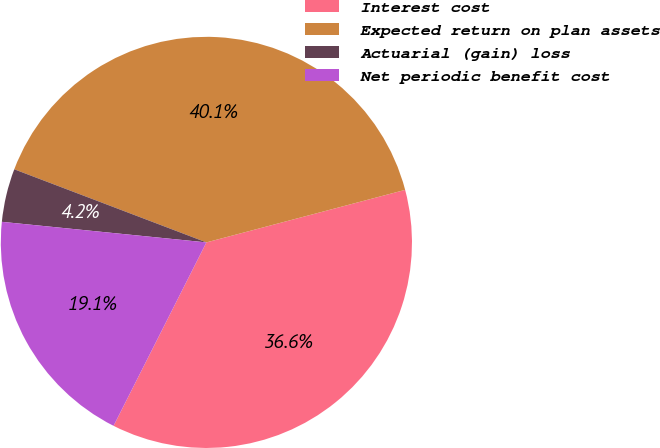Convert chart. <chart><loc_0><loc_0><loc_500><loc_500><pie_chart><fcel>Interest cost<fcel>Expected return on plan assets<fcel>Actuarial (gain) loss<fcel>Net periodic benefit cost<nl><fcel>36.57%<fcel>40.1%<fcel>4.19%<fcel>19.14%<nl></chart> 